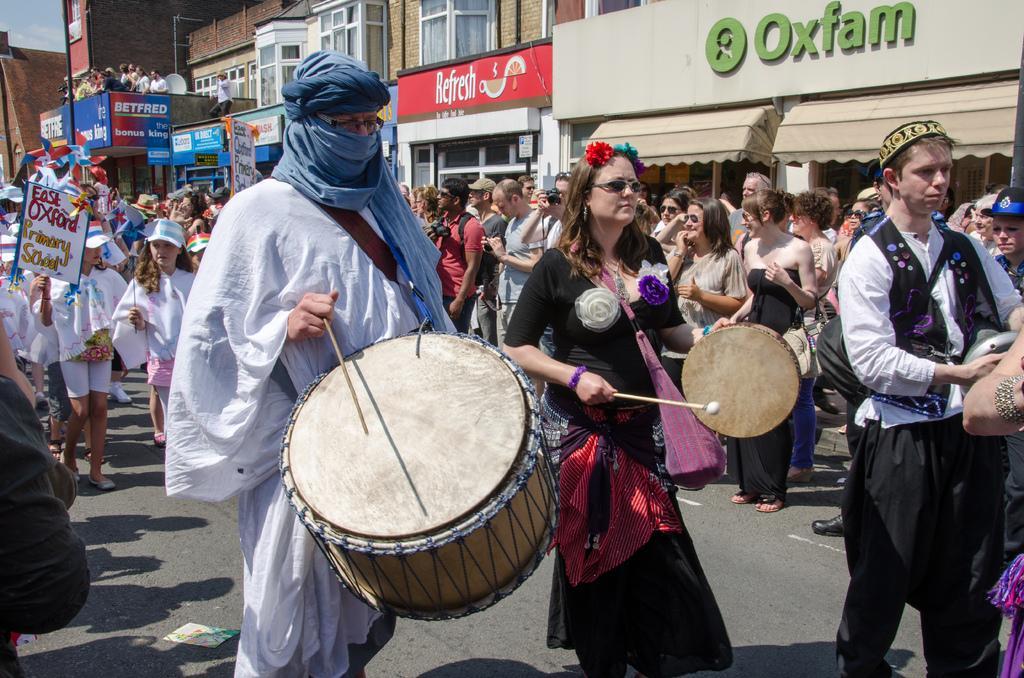How would you summarize this image in a sentence or two? Here we see few buildings and some group of people walking all the streets and a man playing drums and even a woman playing a small drum. 